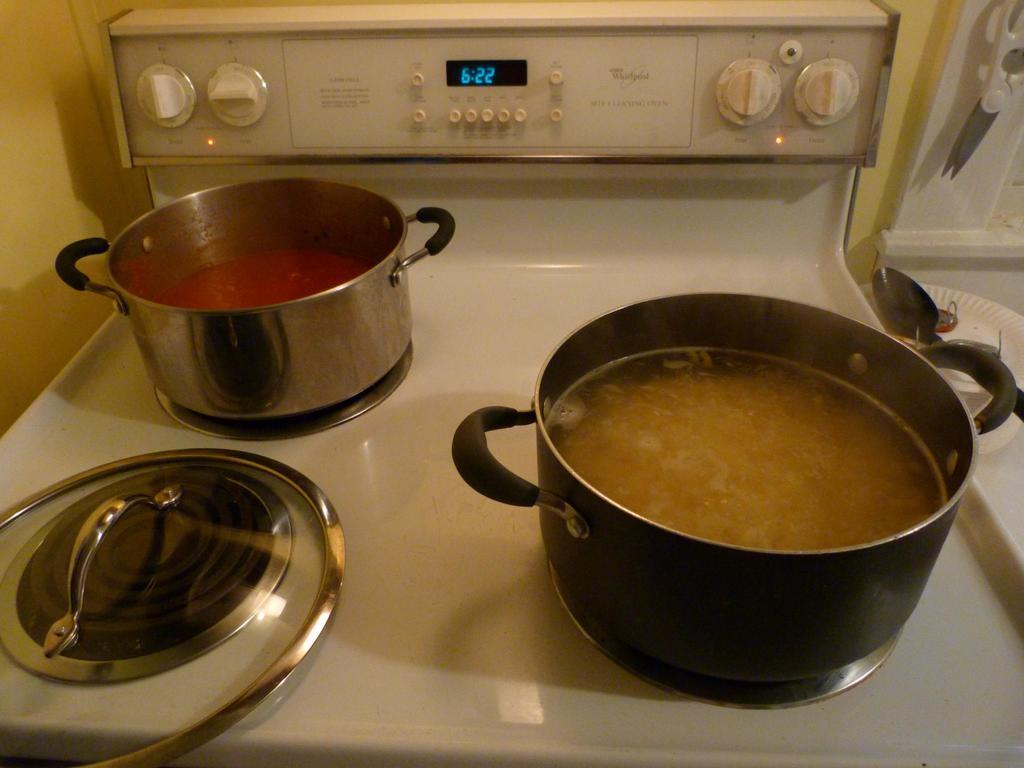<image>
Provide a brief description of the given image. Two different pots of food are on a Whirlpool stove. 